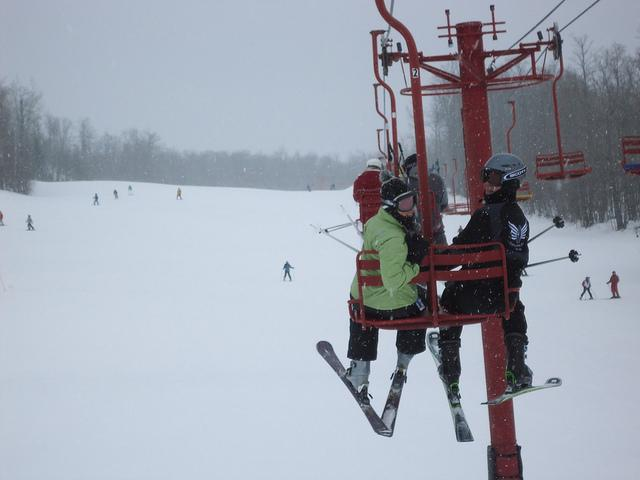Why are they so high up?

Choices:
A) broken mechanism
B) carrying uphill
C) lost
D) daredevils carrying uphill 